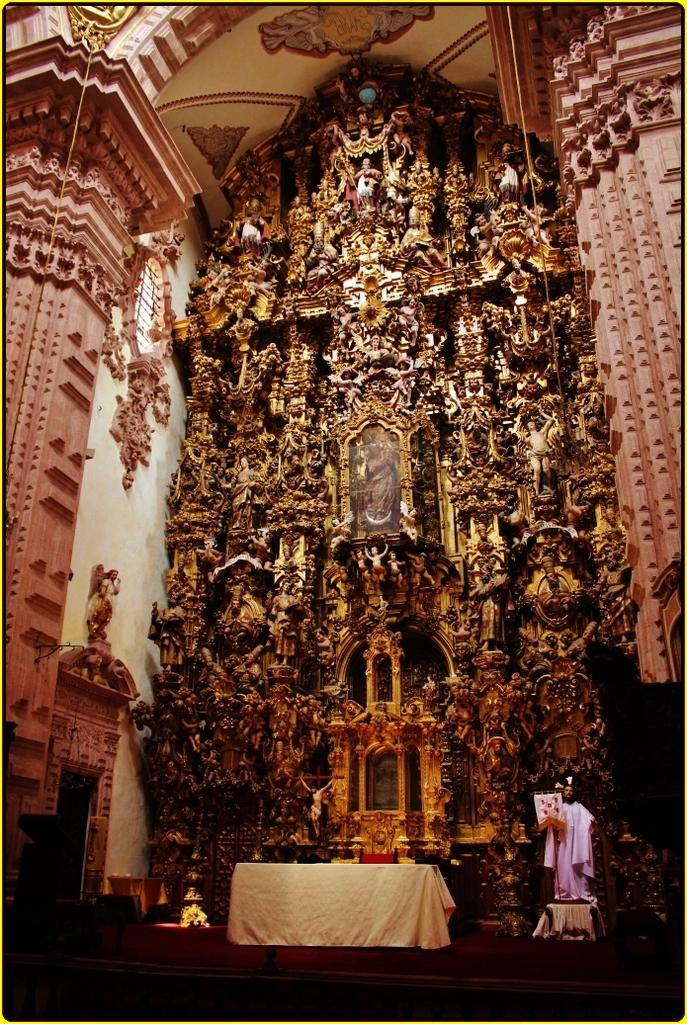What type of art is present in the image? There are sculptures in the image. What is the background of the image? There is a wall in the image. What else can be seen in the image besides the sculptures and wall? There are objects and cloth visible in the image. Where is the rope located in the image? The rope is on the left side of the image. What is at the bottom of the image? There is railing at the bottom of the image. What type of nerve is visible in the image? There is no nerve present in the image. What kind of loaf is being used to support the sculptures in the image? There is no loaf present in the image; the sculptures are not supported by any loaf. 